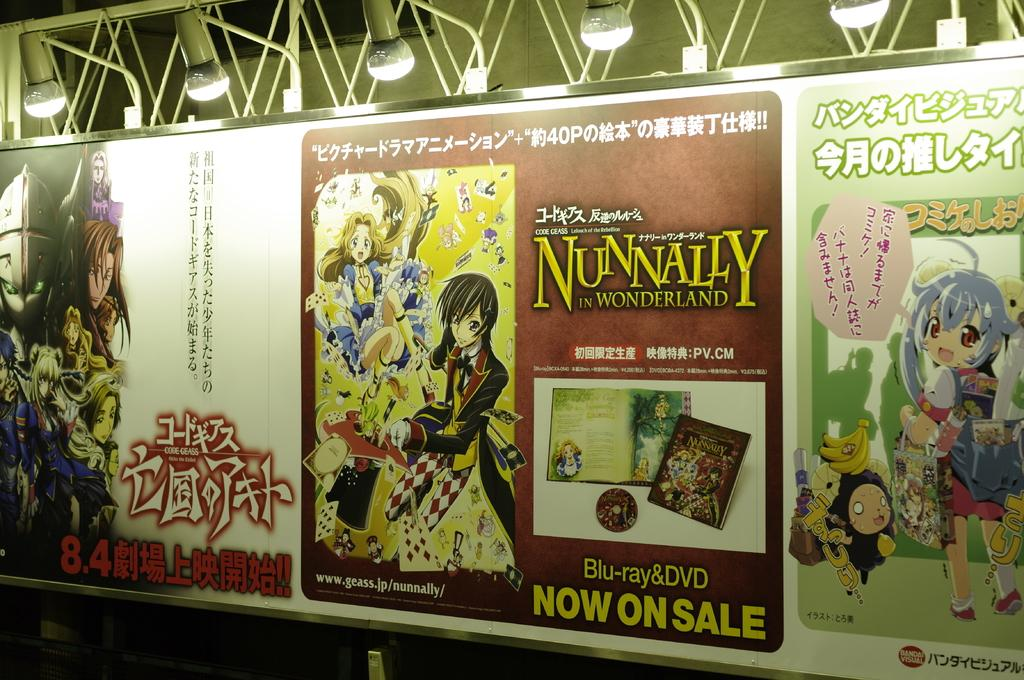<image>
Present a compact description of the photo's key features. Advertisement for a show that is called nunnally 